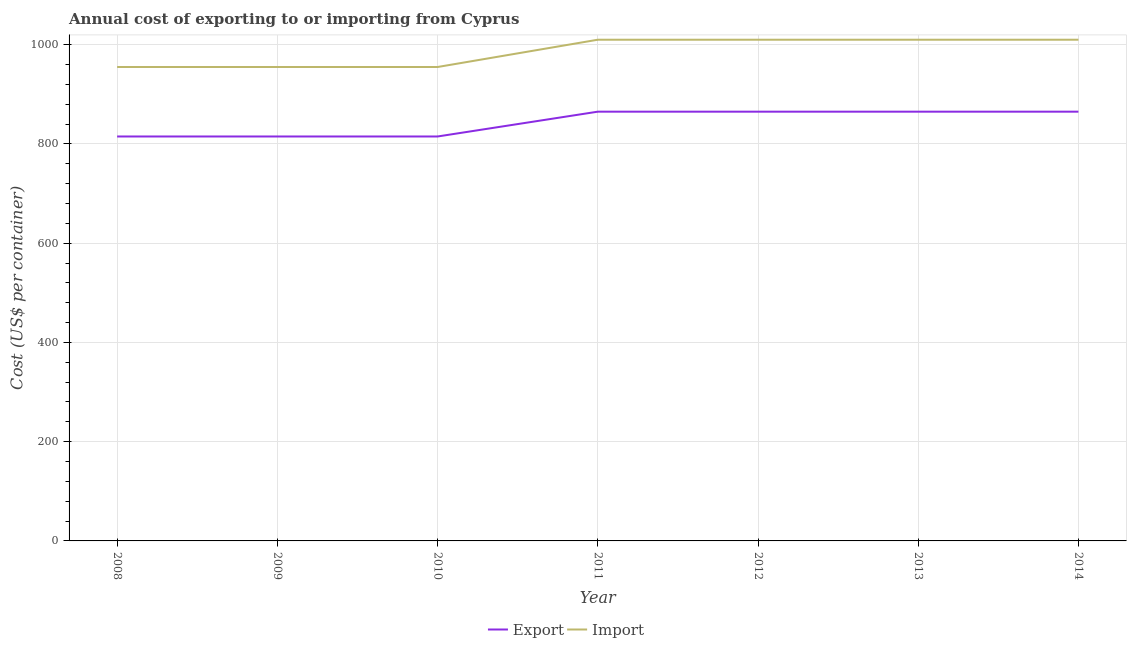Does the line corresponding to import cost intersect with the line corresponding to export cost?
Offer a terse response. No. What is the import cost in 2009?
Provide a short and direct response. 955. Across all years, what is the maximum export cost?
Your response must be concise. 865. Across all years, what is the minimum import cost?
Provide a short and direct response. 955. In which year was the export cost maximum?
Offer a very short reply. 2011. What is the total export cost in the graph?
Offer a terse response. 5905. What is the difference between the import cost in 2011 and that in 2013?
Keep it short and to the point. 0. What is the difference between the export cost in 2008 and the import cost in 2009?
Offer a very short reply. -140. What is the average export cost per year?
Your answer should be very brief. 843.57. In the year 2009, what is the difference between the export cost and import cost?
Make the answer very short. -140. What is the ratio of the export cost in 2010 to that in 2011?
Your answer should be compact. 0.94. Is the export cost in 2008 less than that in 2010?
Offer a terse response. No. Is the difference between the export cost in 2009 and 2013 greater than the difference between the import cost in 2009 and 2013?
Provide a short and direct response. Yes. What is the difference between the highest and the second highest export cost?
Your answer should be compact. 0. What is the difference between the highest and the lowest export cost?
Offer a terse response. 50. In how many years, is the import cost greater than the average import cost taken over all years?
Provide a succinct answer. 4. Is the sum of the export cost in 2010 and 2012 greater than the maximum import cost across all years?
Your answer should be very brief. Yes. Does the import cost monotonically increase over the years?
Give a very brief answer. No. Is the import cost strictly greater than the export cost over the years?
Give a very brief answer. Yes. How many years are there in the graph?
Keep it short and to the point. 7. What is the difference between two consecutive major ticks on the Y-axis?
Offer a terse response. 200. Are the values on the major ticks of Y-axis written in scientific E-notation?
Your answer should be compact. No. Where does the legend appear in the graph?
Provide a succinct answer. Bottom center. How many legend labels are there?
Offer a very short reply. 2. How are the legend labels stacked?
Keep it short and to the point. Horizontal. What is the title of the graph?
Provide a succinct answer. Annual cost of exporting to or importing from Cyprus. What is the label or title of the Y-axis?
Provide a short and direct response. Cost (US$ per container). What is the Cost (US$ per container) of Export in 2008?
Your answer should be very brief. 815. What is the Cost (US$ per container) in Import in 2008?
Your answer should be compact. 955. What is the Cost (US$ per container) of Export in 2009?
Offer a very short reply. 815. What is the Cost (US$ per container) of Import in 2009?
Give a very brief answer. 955. What is the Cost (US$ per container) of Export in 2010?
Your response must be concise. 815. What is the Cost (US$ per container) in Import in 2010?
Offer a terse response. 955. What is the Cost (US$ per container) in Export in 2011?
Keep it short and to the point. 865. What is the Cost (US$ per container) in Import in 2011?
Give a very brief answer. 1010. What is the Cost (US$ per container) of Export in 2012?
Offer a very short reply. 865. What is the Cost (US$ per container) in Import in 2012?
Give a very brief answer. 1010. What is the Cost (US$ per container) of Export in 2013?
Keep it short and to the point. 865. What is the Cost (US$ per container) of Import in 2013?
Give a very brief answer. 1010. What is the Cost (US$ per container) of Export in 2014?
Offer a terse response. 865. What is the Cost (US$ per container) in Import in 2014?
Provide a succinct answer. 1010. Across all years, what is the maximum Cost (US$ per container) of Export?
Offer a very short reply. 865. Across all years, what is the maximum Cost (US$ per container) of Import?
Your response must be concise. 1010. Across all years, what is the minimum Cost (US$ per container) in Export?
Ensure brevity in your answer.  815. Across all years, what is the minimum Cost (US$ per container) in Import?
Offer a very short reply. 955. What is the total Cost (US$ per container) in Export in the graph?
Make the answer very short. 5905. What is the total Cost (US$ per container) of Import in the graph?
Give a very brief answer. 6905. What is the difference between the Cost (US$ per container) of Import in 2008 and that in 2010?
Your answer should be very brief. 0. What is the difference between the Cost (US$ per container) of Import in 2008 and that in 2011?
Ensure brevity in your answer.  -55. What is the difference between the Cost (US$ per container) of Export in 2008 and that in 2012?
Provide a succinct answer. -50. What is the difference between the Cost (US$ per container) of Import in 2008 and that in 2012?
Give a very brief answer. -55. What is the difference between the Cost (US$ per container) in Import in 2008 and that in 2013?
Your answer should be compact. -55. What is the difference between the Cost (US$ per container) of Export in 2008 and that in 2014?
Provide a succinct answer. -50. What is the difference between the Cost (US$ per container) in Import in 2008 and that in 2014?
Offer a very short reply. -55. What is the difference between the Cost (US$ per container) in Import in 2009 and that in 2011?
Offer a very short reply. -55. What is the difference between the Cost (US$ per container) of Import in 2009 and that in 2012?
Ensure brevity in your answer.  -55. What is the difference between the Cost (US$ per container) of Import in 2009 and that in 2013?
Ensure brevity in your answer.  -55. What is the difference between the Cost (US$ per container) of Import in 2009 and that in 2014?
Keep it short and to the point. -55. What is the difference between the Cost (US$ per container) in Import in 2010 and that in 2011?
Keep it short and to the point. -55. What is the difference between the Cost (US$ per container) in Export in 2010 and that in 2012?
Your answer should be compact. -50. What is the difference between the Cost (US$ per container) in Import in 2010 and that in 2012?
Provide a short and direct response. -55. What is the difference between the Cost (US$ per container) in Export in 2010 and that in 2013?
Ensure brevity in your answer.  -50. What is the difference between the Cost (US$ per container) in Import in 2010 and that in 2013?
Provide a short and direct response. -55. What is the difference between the Cost (US$ per container) of Export in 2010 and that in 2014?
Provide a succinct answer. -50. What is the difference between the Cost (US$ per container) in Import in 2010 and that in 2014?
Your response must be concise. -55. What is the difference between the Cost (US$ per container) in Export in 2011 and that in 2012?
Make the answer very short. 0. What is the difference between the Cost (US$ per container) of Export in 2011 and that in 2013?
Your answer should be compact. 0. What is the difference between the Cost (US$ per container) of Export in 2011 and that in 2014?
Keep it short and to the point. 0. What is the difference between the Cost (US$ per container) in Import in 2011 and that in 2014?
Your answer should be compact. 0. What is the difference between the Cost (US$ per container) in Export in 2012 and that in 2013?
Ensure brevity in your answer.  0. What is the difference between the Cost (US$ per container) in Import in 2012 and that in 2013?
Offer a very short reply. 0. What is the difference between the Cost (US$ per container) of Export in 2013 and that in 2014?
Your answer should be compact. 0. What is the difference between the Cost (US$ per container) in Export in 2008 and the Cost (US$ per container) in Import in 2009?
Keep it short and to the point. -140. What is the difference between the Cost (US$ per container) in Export in 2008 and the Cost (US$ per container) in Import in 2010?
Give a very brief answer. -140. What is the difference between the Cost (US$ per container) in Export in 2008 and the Cost (US$ per container) in Import in 2011?
Provide a succinct answer. -195. What is the difference between the Cost (US$ per container) in Export in 2008 and the Cost (US$ per container) in Import in 2012?
Your response must be concise. -195. What is the difference between the Cost (US$ per container) of Export in 2008 and the Cost (US$ per container) of Import in 2013?
Make the answer very short. -195. What is the difference between the Cost (US$ per container) of Export in 2008 and the Cost (US$ per container) of Import in 2014?
Your answer should be compact. -195. What is the difference between the Cost (US$ per container) in Export in 2009 and the Cost (US$ per container) in Import in 2010?
Ensure brevity in your answer.  -140. What is the difference between the Cost (US$ per container) in Export in 2009 and the Cost (US$ per container) in Import in 2011?
Ensure brevity in your answer.  -195. What is the difference between the Cost (US$ per container) of Export in 2009 and the Cost (US$ per container) of Import in 2012?
Your response must be concise. -195. What is the difference between the Cost (US$ per container) in Export in 2009 and the Cost (US$ per container) in Import in 2013?
Ensure brevity in your answer.  -195. What is the difference between the Cost (US$ per container) in Export in 2009 and the Cost (US$ per container) in Import in 2014?
Offer a very short reply. -195. What is the difference between the Cost (US$ per container) in Export in 2010 and the Cost (US$ per container) in Import in 2011?
Make the answer very short. -195. What is the difference between the Cost (US$ per container) of Export in 2010 and the Cost (US$ per container) of Import in 2012?
Make the answer very short. -195. What is the difference between the Cost (US$ per container) of Export in 2010 and the Cost (US$ per container) of Import in 2013?
Ensure brevity in your answer.  -195. What is the difference between the Cost (US$ per container) in Export in 2010 and the Cost (US$ per container) in Import in 2014?
Offer a terse response. -195. What is the difference between the Cost (US$ per container) of Export in 2011 and the Cost (US$ per container) of Import in 2012?
Keep it short and to the point. -145. What is the difference between the Cost (US$ per container) of Export in 2011 and the Cost (US$ per container) of Import in 2013?
Make the answer very short. -145. What is the difference between the Cost (US$ per container) in Export in 2011 and the Cost (US$ per container) in Import in 2014?
Offer a very short reply. -145. What is the difference between the Cost (US$ per container) in Export in 2012 and the Cost (US$ per container) in Import in 2013?
Offer a terse response. -145. What is the difference between the Cost (US$ per container) in Export in 2012 and the Cost (US$ per container) in Import in 2014?
Provide a short and direct response. -145. What is the difference between the Cost (US$ per container) of Export in 2013 and the Cost (US$ per container) of Import in 2014?
Offer a terse response. -145. What is the average Cost (US$ per container) of Export per year?
Provide a succinct answer. 843.57. What is the average Cost (US$ per container) in Import per year?
Offer a very short reply. 986.43. In the year 2008, what is the difference between the Cost (US$ per container) in Export and Cost (US$ per container) in Import?
Keep it short and to the point. -140. In the year 2009, what is the difference between the Cost (US$ per container) of Export and Cost (US$ per container) of Import?
Your response must be concise. -140. In the year 2010, what is the difference between the Cost (US$ per container) of Export and Cost (US$ per container) of Import?
Your response must be concise. -140. In the year 2011, what is the difference between the Cost (US$ per container) in Export and Cost (US$ per container) in Import?
Provide a succinct answer. -145. In the year 2012, what is the difference between the Cost (US$ per container) in Export and Cost (US$ per container) in Import?
Offer a very short reply. -145. In the year 2013, what is the difference between the Cost (US$ per container) in Export and Cost (US$ per container) in Import?
Your answer should be compact. -145. In the year 2014, what is the difference between the Cost (US$ per container) of Export and Cost (US$ per container) of Import?
Your response must be concise. -145. What is the ratio of the Cost (US$ per container) in Export in 2008 to that in 2009?
Make the answer very short. 1. What is the ratio of the Cost (US$ per container) of Import in 2008 to that in 2010?
Keep it short and to the point. 1. What is the ratio of the Cost (US$ per container) in Export in 2008 to that in 2011?
Keep it short and to the point. 0.94. What is the ratio of the Cost (US$ per container) in Import in 2008 to that in 2011?
Your response must be concise. 0.95. What is the ratio of the Cost (US$ per container) in Export in 2008 to that in 2012?
Provide a succinct answer. 0.94. What is the ratio of the Cost (US$ per container) in Import in 2008 to that in 2012?
Provide a succinct answer. 0.95. What is the ratio of the Cost (US$ per container) in Export in 2008 to that in 2013?
Offer a terse response. 0.94. What is the ratio of the Cost (US$ per container) of Import in 2008 to that in 2013?
Provide a short and direct response. 0.95. What is the ratio of the Cost (US$ per container) in Export in 2008 to that in 2014?
Offer a very short reply. 0.94. What is the ratio of the Cost (US$ per container) in Import in 2008 to that in 2014?
Keep it short and to the point. 0.95. What is the ratio of the Cost (US$ per container) of Export in 2009 to that in 2010?
Give a very brief answer. 1. What is the ratio of the Cost (US$ per container) of Export in 2009 to that in 2011?
Offer a very short reply. 0.94. What is the ratio of the Cost (US$ per container) of Import in 2009 to that in 2011?
Your answer should be compact. 0.95. What is the ratio of the Cost (US$ per container) in Export in 2009 to that in 2012?
Keep it short and to the point. 0.94. What is the ratio of the Cost (US$ per container) in Import in 2009 to that in 2012?
Offer a very short reply. 0.95. What is the ratio of the Cost (US$ per container) in Export in 2009 to that in 2013?
Ensure brevity in your answer.  0.94. What is the ratio of the Cost (US$ per container) in Import in 2009 to that in 2013?
Your answer should be compact. 0.95. What is the ratio of the Cost (US$ per container) in Export in 2009 to that in 2014?
Your answer should be very brief. 0.94. What is the ratio of the Cost (US$ per container) of Import in 2009 to that in 2014?
Keep it short and to the point. 0.95. What is the ratio of the Cost (US$ per container) in Export in 2010 to that in 2011?
Keep it short and to the point. 0.94. What is the ratio of the Cost (US$ per container) in Import in 2010 to that in 2011?
Your answer should be very brief. 0.95. What is the ratio of the Cost (US$ per container) in Export in 2010 to that in 2012?
Ensure brevity in your answer.  0.94. What is the ratio of the Cost (US$ per container) in Import in 2010 to that in 2012?
Make the answer very short. 0.95. What is the ratio of the Cost (US$ per container) of Export in 2010 to that in 2013?
Provide a short and direct response. 0.94. What is the ratio of the Cost (US$ per container) of Import in 2010 to that in 2013?
Your answer should be very brief. 0.95. What is the ratio of the Cost (US$ per container) of Export in 2010 to that in 2014?
Your response must be concise. 0.94. What is the ratio of the Cost (US$ per container) of Import in 2010 to that in 2014?
Provide a succinct answer. 0.95. What is the ratio of the Cost (US$ per container) in Export in 2011 to that in 2012?
Your answer should be compact. 1. What is the ratio of the Cost (US$ per container) in Export in 2011 to that in 2013?
Provide a short and direct response. 1. What is the ratio of the Cost (US$ per container) of Import in 2011 to that in 2013?
Make the answer very short. 1. What is the ratio of the Cost (US$ per container) in Import in 2011 to that in 2014?
Offer a terse response. 1. What is the ratio of the Cost (US$ per container) of Export in 2012 to that in 2013?
Keep it short and to the point. 1. What is the ratio of the Cost (US$ per container) in Export in 2013 to that in 2014?
Your answer should be compact. 1. What is the ratio of the Cost (US$ per container) of Import in 2013 to that in 2014?
Your response must be concise. 1. What is the difference between the highest and the lowest Cost (US$ per container) in Export?
Offer a very short reply. 50. What is the difference between the highest and the lowest Cost (US$ per container) in Import?
Keep it short and to the point. 55. 